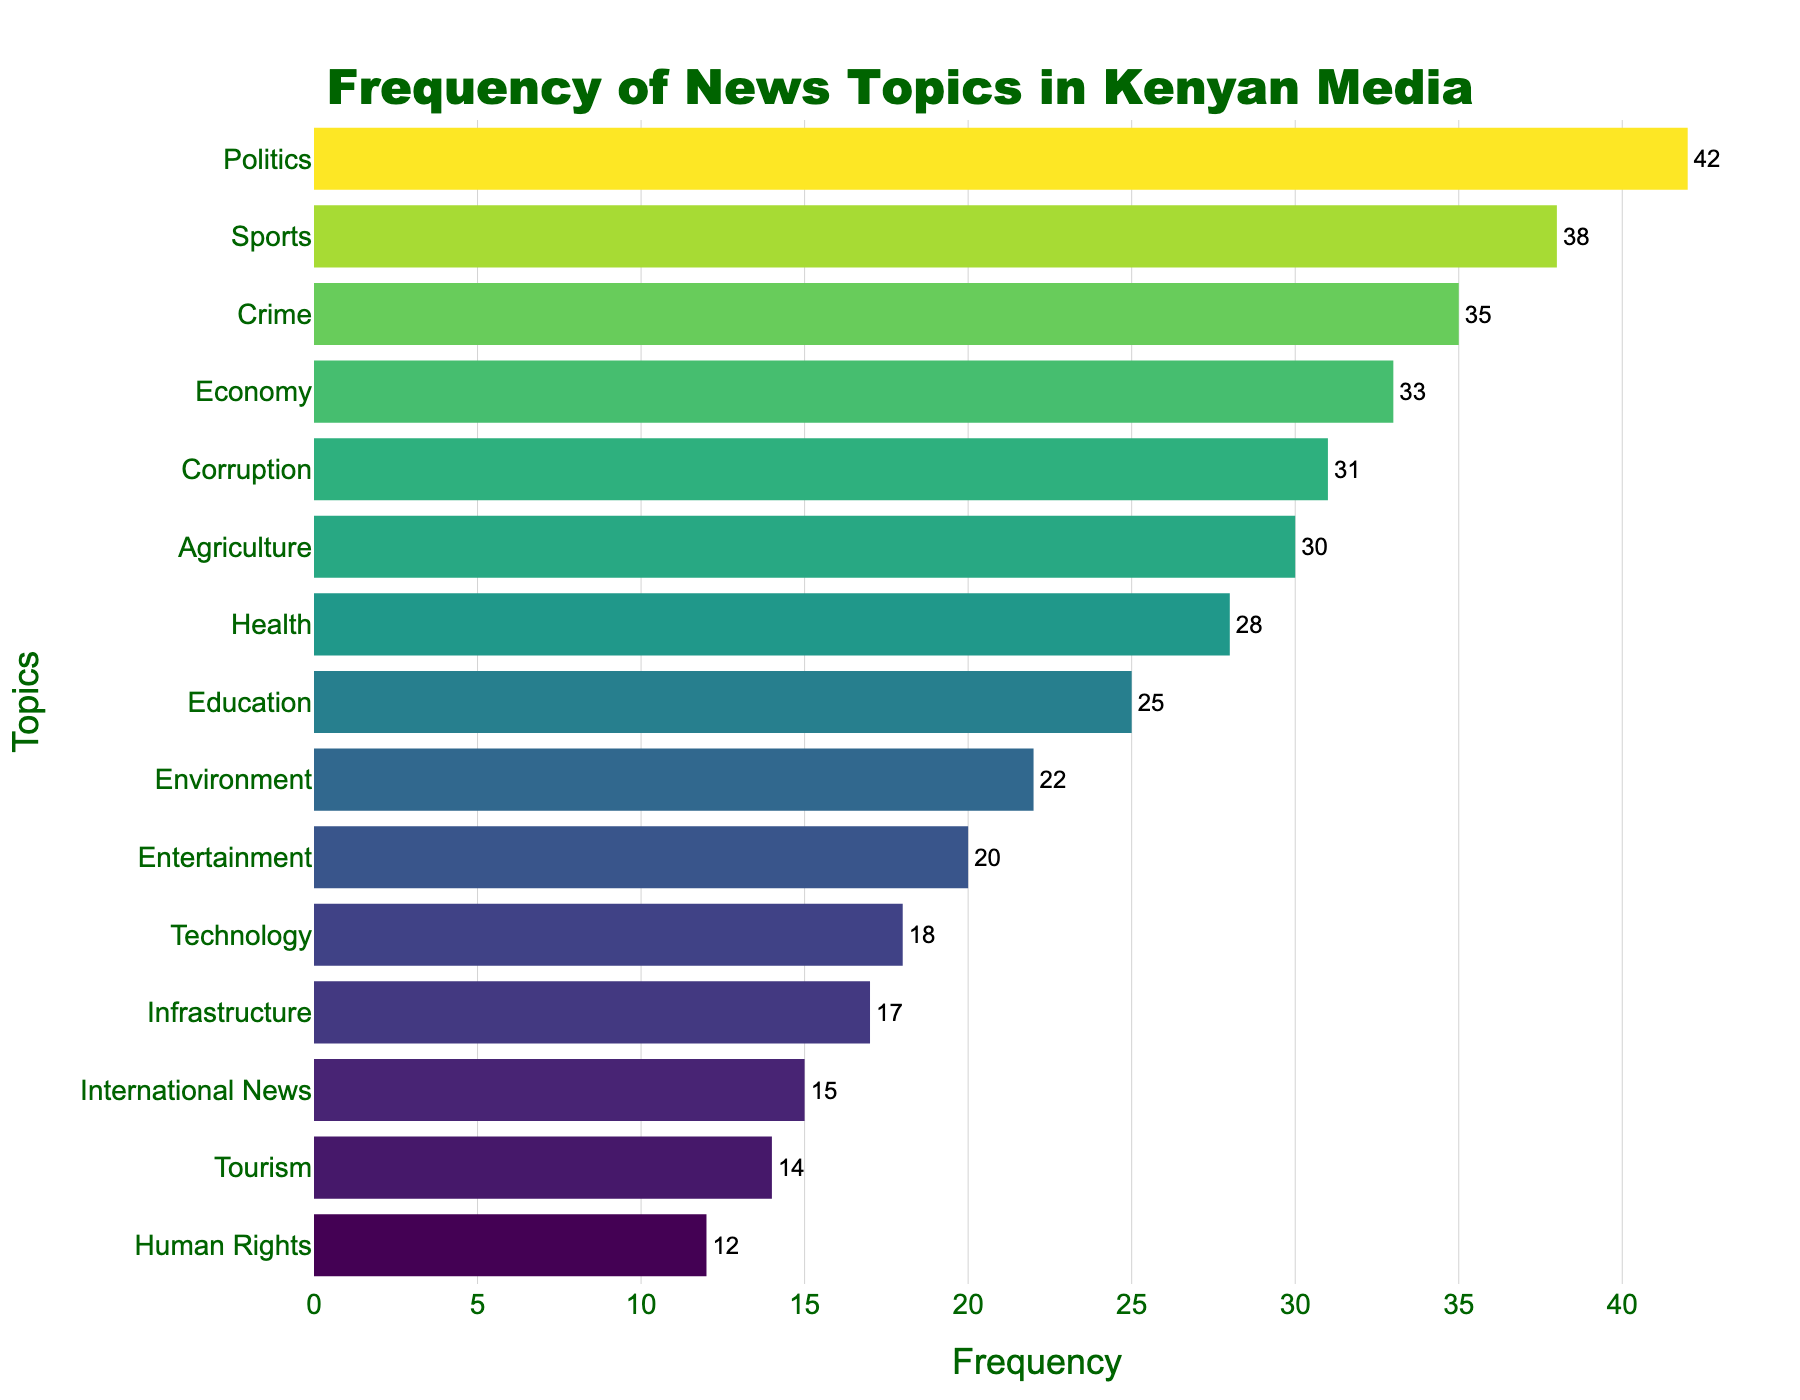What's the title of the plot? The title of the plot is generally placed at the top of the figure and is intended to describe what the figure represents. In this figure, the title reads: "Frequency of News Topics in Kenyan Media".
Answer: Frequency of News Topics in Kenyan Media Which topic is covered most frequently by Kenyan media outlets? To find the topic covered most frequently, look for the bar with the highest value on the x-axis. "Politics" has the highest frequency.
Answer: Politics Which topic has the lowest frequency of coverage? To find the least covered topic, identify the bar with the smallest value on the x-axis. "Human Rights" has the lowest frequency.
Answer: Human Rights What is the total frequency of all topics related to education and health combined? Locate the bars for Education and Health and sum their frequencies. Education has 25, and Health has 28. Adding them together: 25 + 28 = 53.
Answer: 53 Are there more topics covered less frequently than 20 times or those covered more frequently than 30 times? Count the number of topics with frequencies less than 20 and those with frequencies more than 30. Topics less than 20: Technology (18), Tourism (14), International News (15), Human Rights (12). Topics more than 30: Politics (42), Crime (35), Economy (33), Sports (38), Corruption (31). There are 4 topics with less than 20 and 5 topics with more than 30.
Answer: More topics covered more than 30 times How much more frequent is the coverage of Sports compared to Entertainment? Locate the frequencies for Sports and Entertainment and subtract the latter from the former. Sports has 38, and Entertainment has 20. Subtracting them: 38 - 20 = 18.
Answer: 18 What's the median frequency of all the topics covered? To find the median frequency, list all frequencies in ascending order and find the middle value. Frequencies are: 12, 14, 15, 17, 18, 20, 22, 25, 28, 30, 31, 33, 35, 38, 42. The middle value (8th in order) is 25.
Answer: 25 Which topic has a frequency closest to the average frequency? First, calculate the average frequency. Sum all frequencies and divide by the number of topics: (42 + 35 + 28 + 25 + 33 + 30 + 38 + 22 + 18 + 20 + 15 + 12 + 31 + 17 + 14)/15 = 24.8. Check the frequencies to see which is closest to 24.8. Education has 25 which is closest.
Answer: Education What is the combined frequency of Agriculture, Crime, and Technology topics? Locate the bars for Agriculture, Crime, and Technology and sum their frequencies. Agriculture has 30, Crime has 35, and Technology has 18. Adding them together: 30 + 35 + 18 = 83.
Answer: 83 